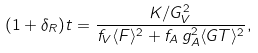Convert formula to latex. <formula><loc_0><loc_0><loc_500><loc_500>( 1 + \delta _ { R } ) t = \frac { K / G _ { V } ^ { 2 } } { f _ { V } \langle { F } \rangle ^ { 2 } + f _ { A } \, g _ { A } ^ { 2 } \langle { G T } \rangle ^ { 2 } } ,</formula> 